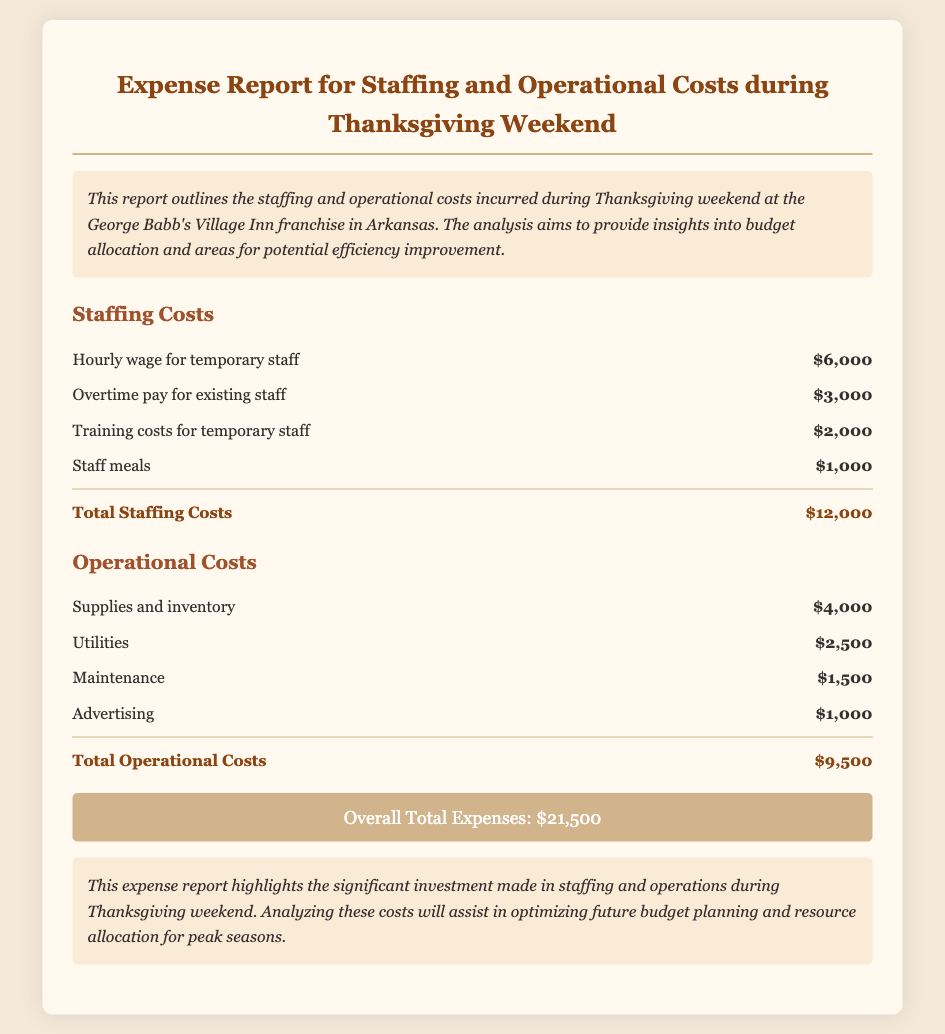What is the total staffing cost? The total staffing cost is mentioned in the document as $12,000.
Answer: $12,000 What are the training costs for temporary staff? The training costs for temporary staff are detailed in the document as $2,000.
Answer: $2,000 What is the total operational cost? The total operational cost is explicitly stated in the document as $9,500.
Answer: $9,500 What is the overall total expense for Thanksgiving weekend? The overall total expense is summarized in the document as $21,500.
Answer: $21,500 How much was spent on staff meals? The expenditure on staff meals is specified in the document as $1,000.
Answer: $1,000 What is the cost of utilities? The cost of utilities is listed in the document as $2,500.
Answer: $2,500 Which category has the highest expenditure? The category with the highest expenditure is staffing costs, totaling $12,000.
Answer: Staffing Costs How much was allocated for advertising? The allocation for advertising is noted in the document as $1,000.
Answer: $1,000 What amount was spent on supplies and inventory? The expenditure on supplies and inventory is reported as $4,000 in the document.
Answer: $4,000 